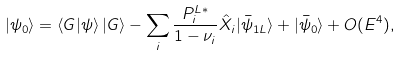<formula> <loc_0><loc_0><loc_500><loc_500>| \psi _ { 0 } \rangle = \langle G | \psi \rangle \, | G \rangle - \sum _ { i } \frac { P _ { i } ^ { L * } } { 1 - \nu _ { i } } { \hat { X } } _ { i } | \bar { \psi } _ { 1 L } \rangle + | \bar { \psi } _ { 0 } \rangle + O ( E ^ { 4 } ) ,</formula> 